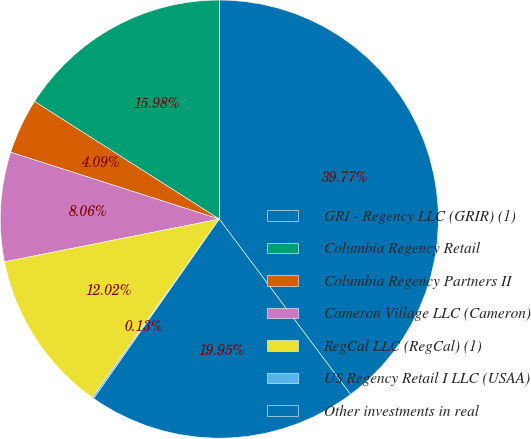Convert chart to OTSL. <chart><loc_0><loc_0><loc_500><loc_500><pie_chart><fcel>GRI - Regency LLC (GRIR) (1)<fcel>Columbia Regency Retail<fcel>Columbia Regency Partners II<fcel>Cameron Village LLC (Cameron)<fcel>RegCal LLC (RegCal) (1)<fcel>US Regency Retail I LLC (USAA)<fcel>Other investments in real<nl><fcel>39.77%<fcel>15.98%<fcel>4.09%<fcel>8.06%<fcel>12.02%<fcel>0.13%<fcel>19.95%<nl></chart> 